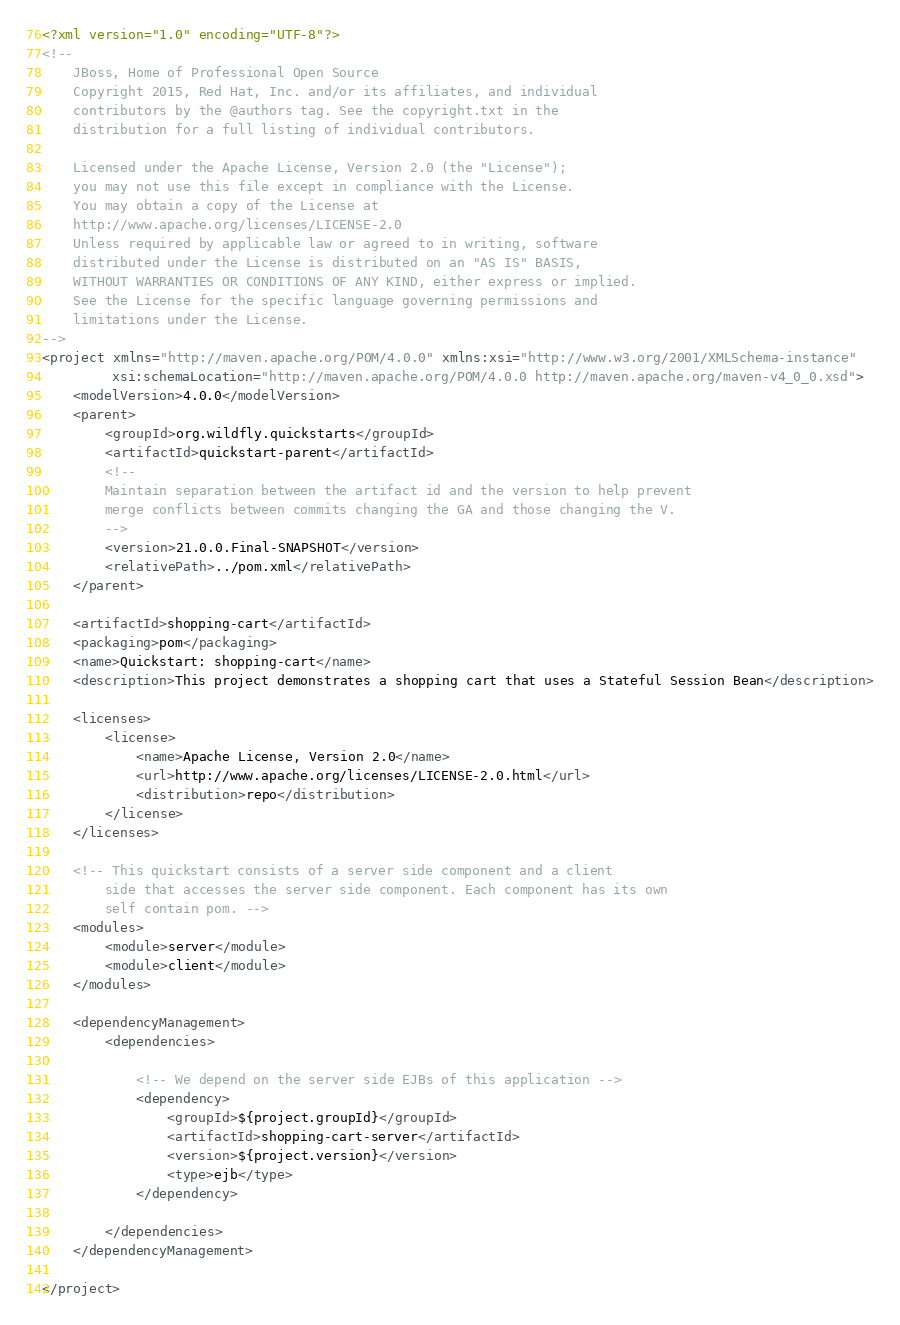<code> <loc_0><loc_0><loc_500><loc_500><_XML_><?xml version="1.0" encoding="UTF-8"?>
<!--
    JBoss, Home of Professional Open Source
    Copyright 2015, Red Hat, Inc. and/or its affiliates, and individual
    contributors by the @authors tag. See the copyright.txt in the
    distribution for a full listing of individual contributors.

    Licensed under the Apache License, Version 2.0 (the "License");
    you may not use this file except in compliance with the License.
    You may obtain a copy of the License at
    http://www.apache.org/licenses/LICENSE-2.0
    Unless required by applicable law or agreed to in writing, software
    distributed under the License is distributed on an "AS IS" BASIS,
    WITHOUT WARRANTIES OR CONDITIONS OF ANY KIND, either express or implied.
    See the License for the specific language governing permissions and
    limitations under the License.
-->
<project xmlns="http://maven.apache.org/POM/4.0.0" xmlns:xsi="http://www.w3.org/2001/XMLSchema-instance"
         xsi:schemaLocation="http://maven.apache.org/POM/4.0.0 http://maven.apache.org/maven-v4_0_0.xsd">
    <modelVersion>4.0.0</modelVersion>
    <parent>
        <groupId>org.wildfly.quickstarts</groupId>
        <artifactId>quickstart-parent</artifactId>
        <!--
        Maintain separation between the artifact id and the version to help prevent
        merge conflicts between commits changing the GA and those changing the V.
        -->
        <version>21.0.0.Final-SNAPSHOT</version>
        <relativePath>../pom.xml</relativePath>
    </parent>

    <artifactId>shopping-cart</artifactId>
    <packaging>pom</packaging>
    <name>Quickstart: shopping-cart</name>
    <description>This project demonstrates a shopping cart that uses a Stateful Session Bean</description>

    <licenses>
        <license>
            <name>Apache License, Version 2.0</name>
            <url>http://www.apache.org/licenses/LICENSE-2.0.html</url>
            <distribution>repo</distribution>
        </license>
    </licenses>

    <!-- This quickstart consists of a server side component and a client
        side that accesses the server side component. Each component has its own
        self contain pom. -->
    <modules>
        <module>server</module>
        <module>client</module>
    </modules>

    <dependencyManagement>
        <dependencies>

            <!-- We depend on the server side EJBs of this application -->
            <dependency>
                <groupId>${project.groupId}</groupId>
                <artifactId>shopping-cart-server</artifactId>
                <version>${project.version}</version>
                <type>ejb</type>
            </dependency>

        </dependencies>
    </dependencyManagement>

</project>
</code> 